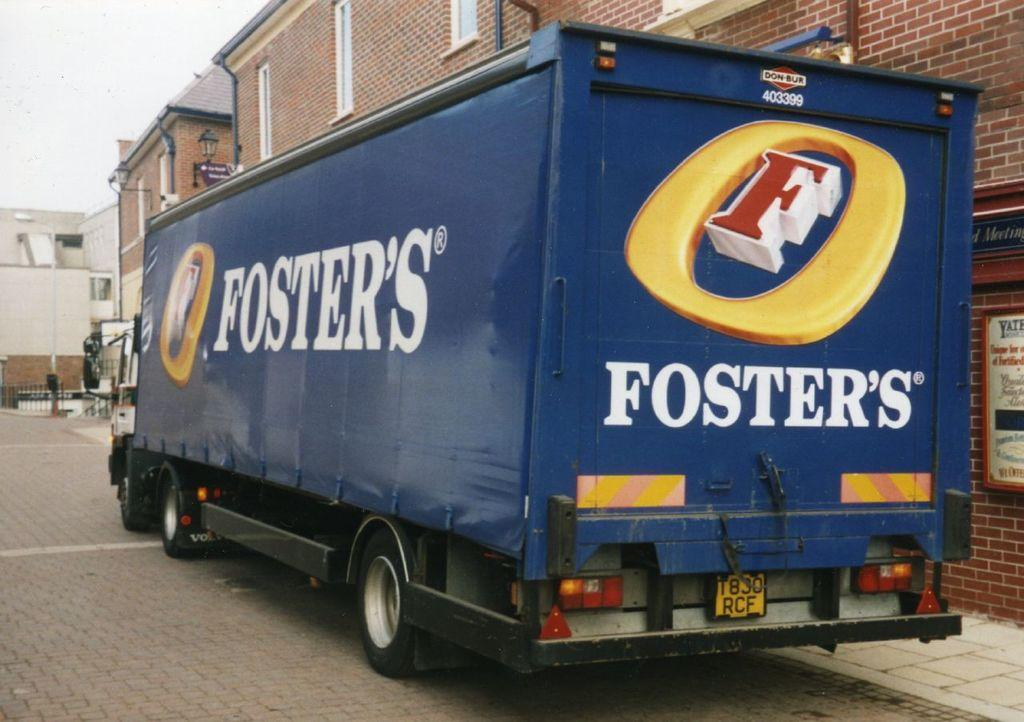What is the main subject of the image? There is a vehicle on the road in the image. What can be seen behind the vehicle? There are buildings behind the vehicle. What type of lighting is present in the image? Street lights are present in the image. What type of barrier is visible in the image? There is a metal fence in the image. What is visible in the background of the image? The sky is visible in the background of the image. What type of pie is being served at the angry protest in the image? There is no pie or protest present in the image; it features a vehicle on the road with buildings, street lights, a metal fence, and the sky visible in the background. 